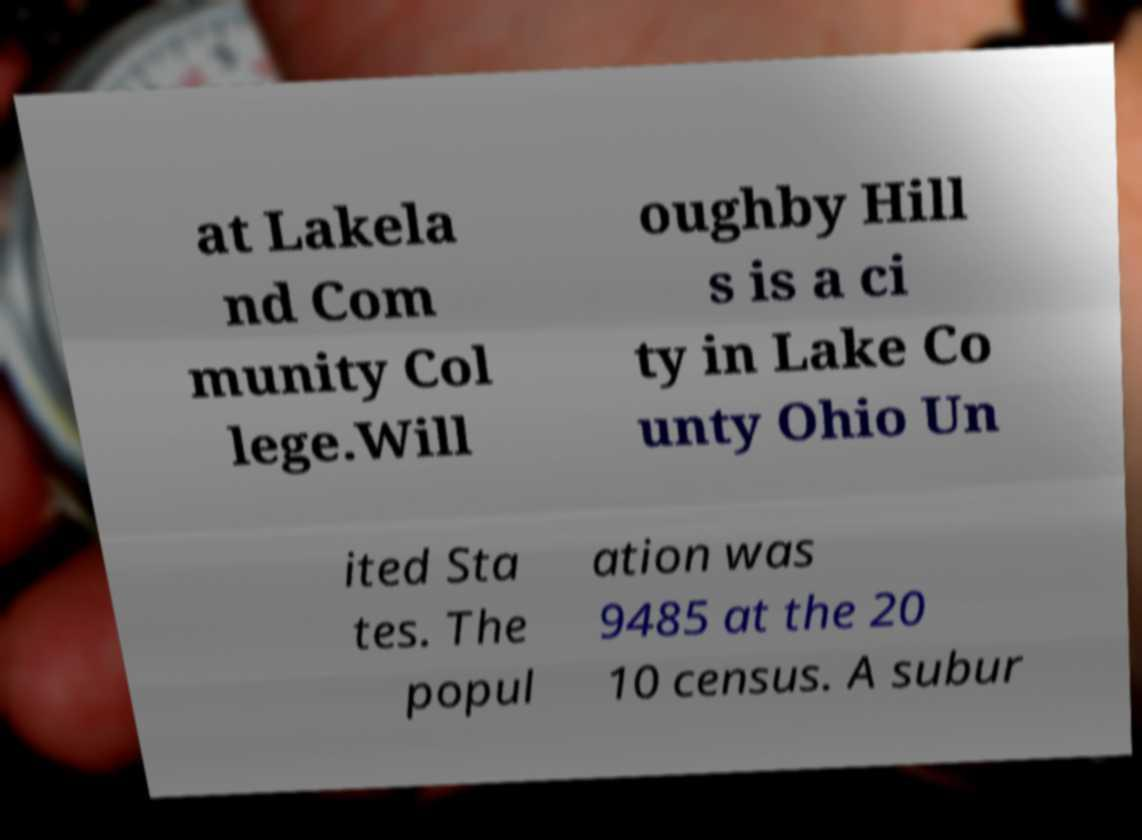Please identify and transcribe the text found in this image. at Lakela nd Com munity Col lege.Will oughby Hill s is a ci ty in Lake Co unty Ohio Un ited Sta tes. The popul ation was 9485 at the 20 10 census. A subur 